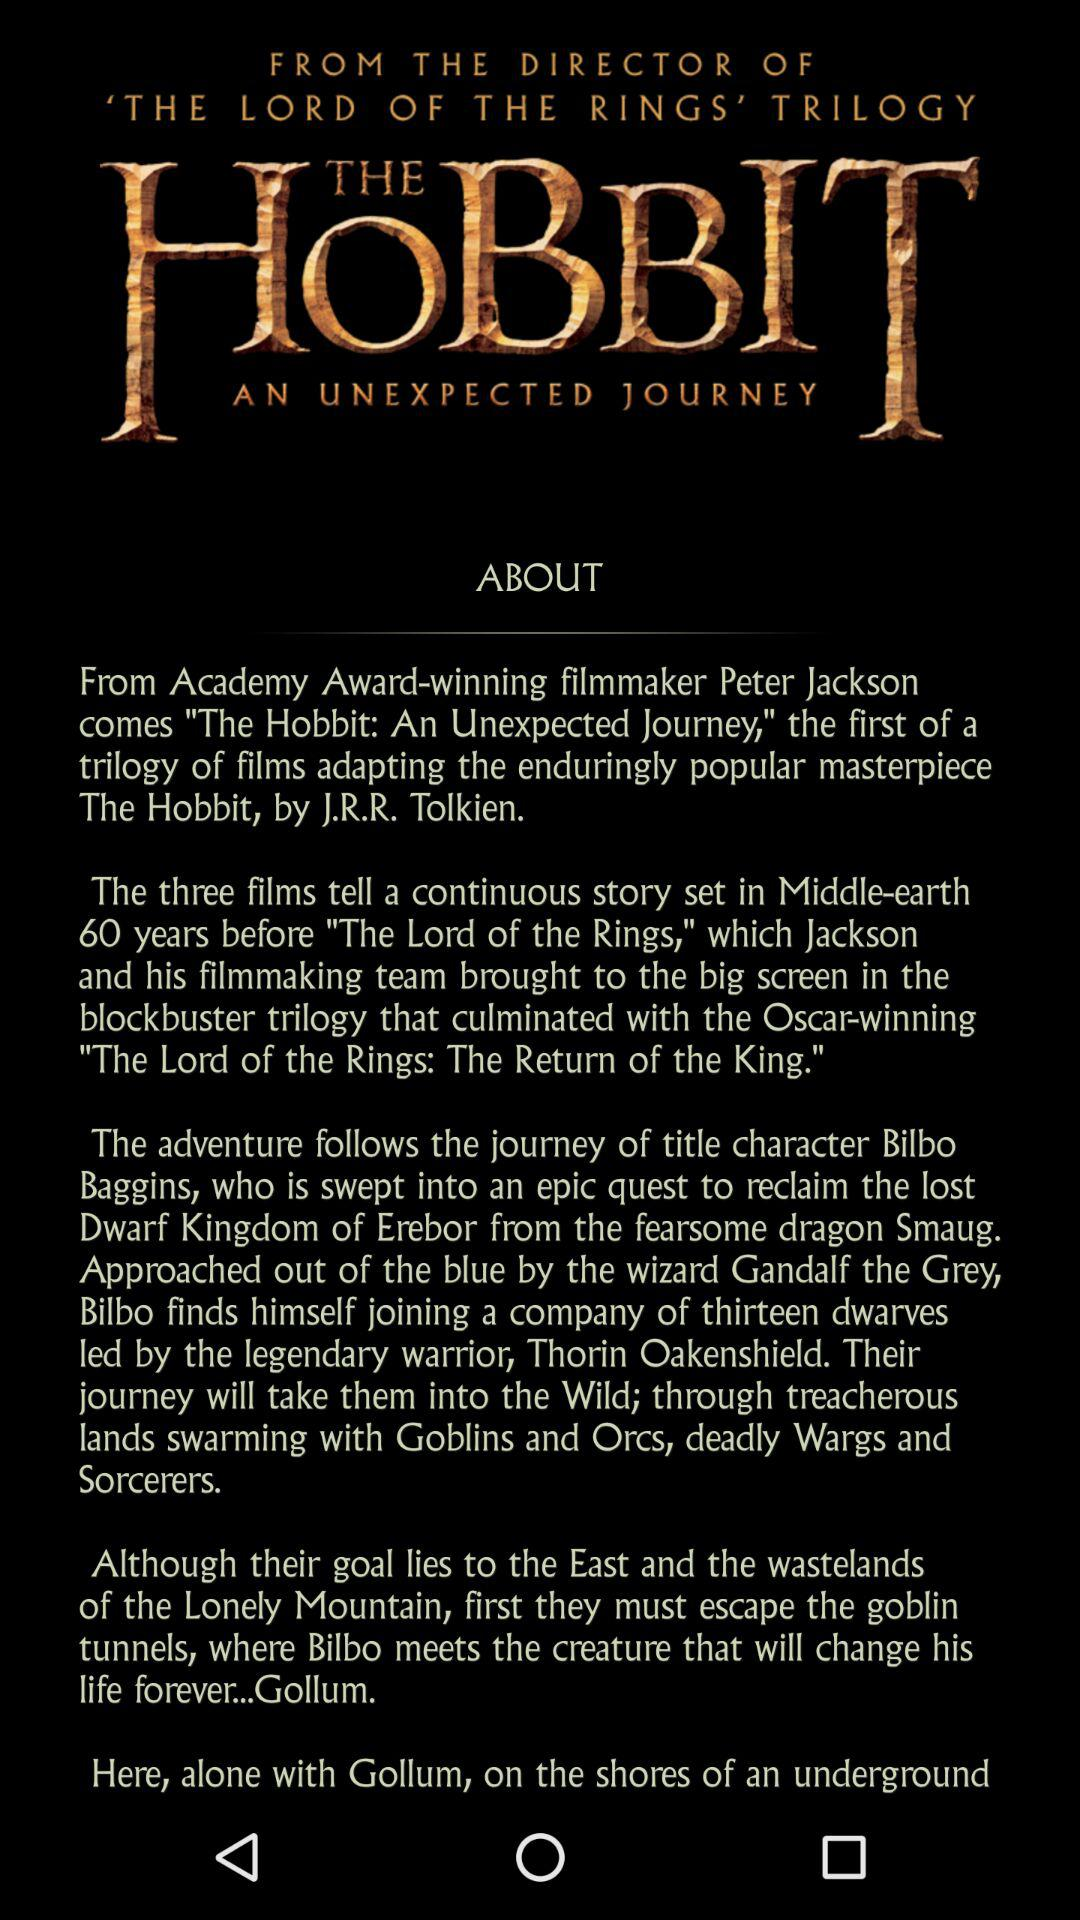Who played the part of "Gollum" in the film trilogy?
When the provided information is insufficient, respond with <no answer>. <no answer> 